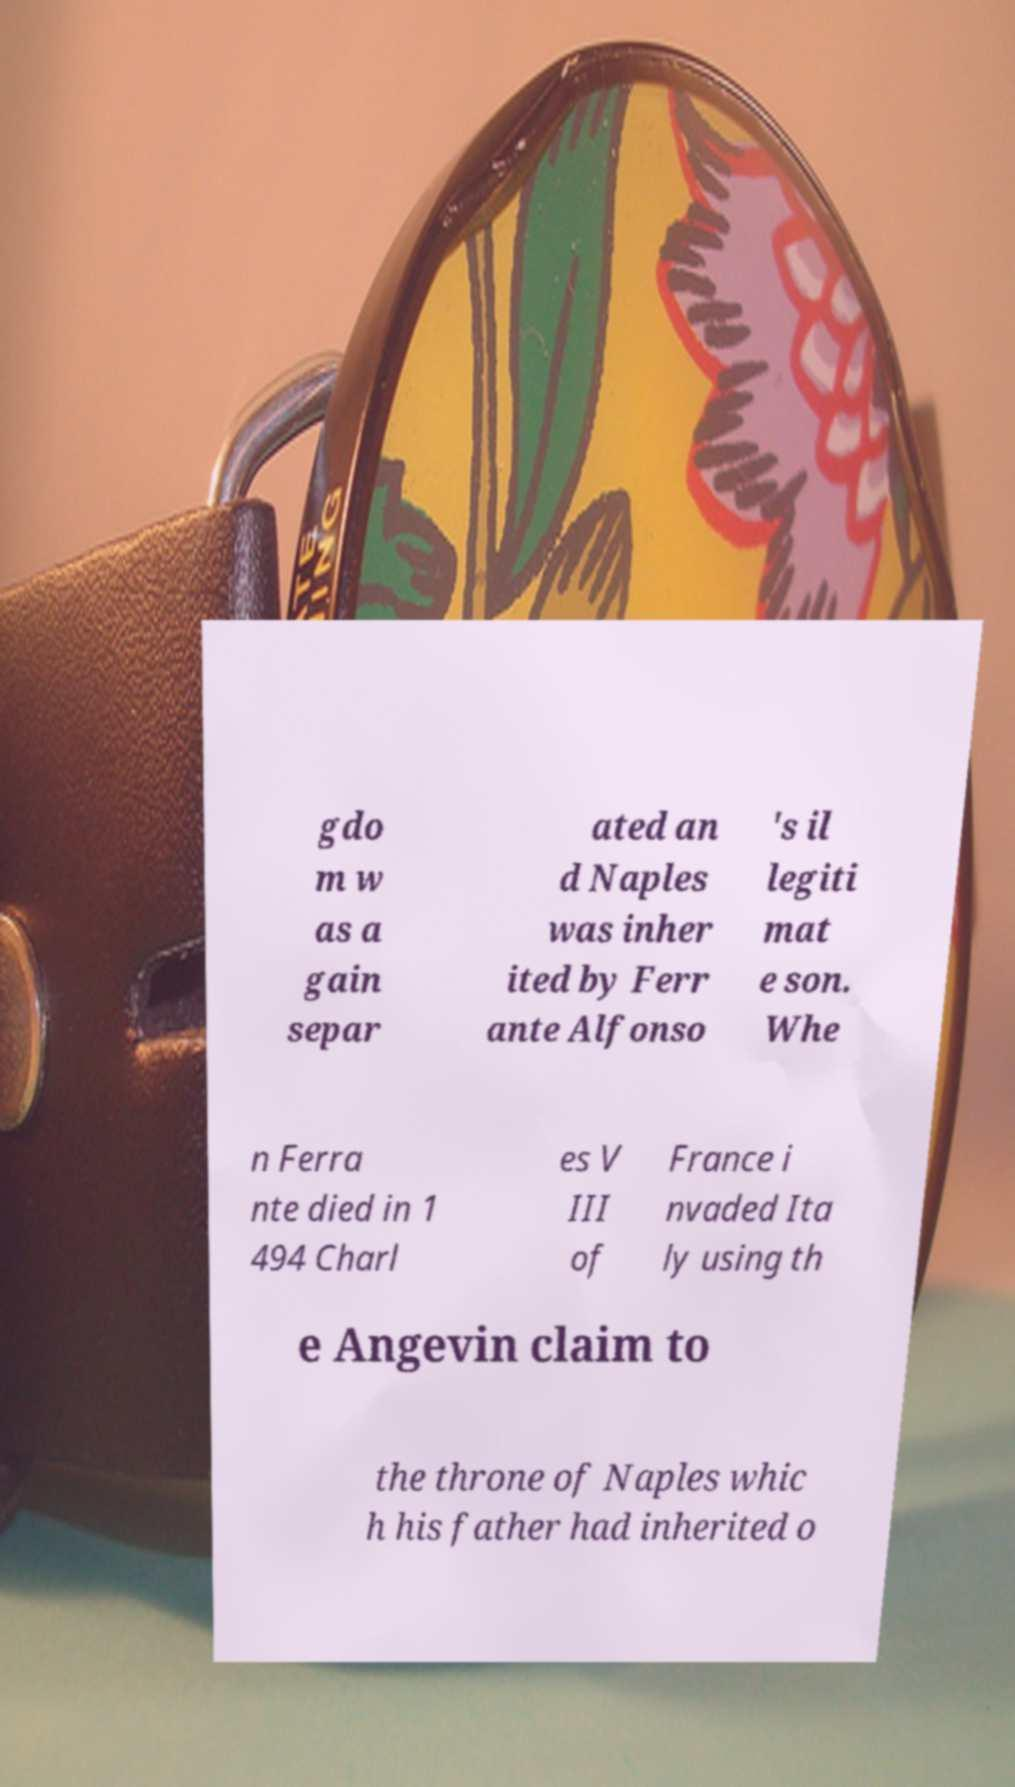What messages or text are displayed in this image? I need them in a readable, typed format. gdo m w as a gain separ ated an d Naples was inher ited by Ferr ante Alfonso 's il legiti mat e son. Whe n Ferra nte died in 1 494 Charl es V III of France i nvaded Ita ly using th e Angevin claim to the throne of Naples whic h his father had inherited o 